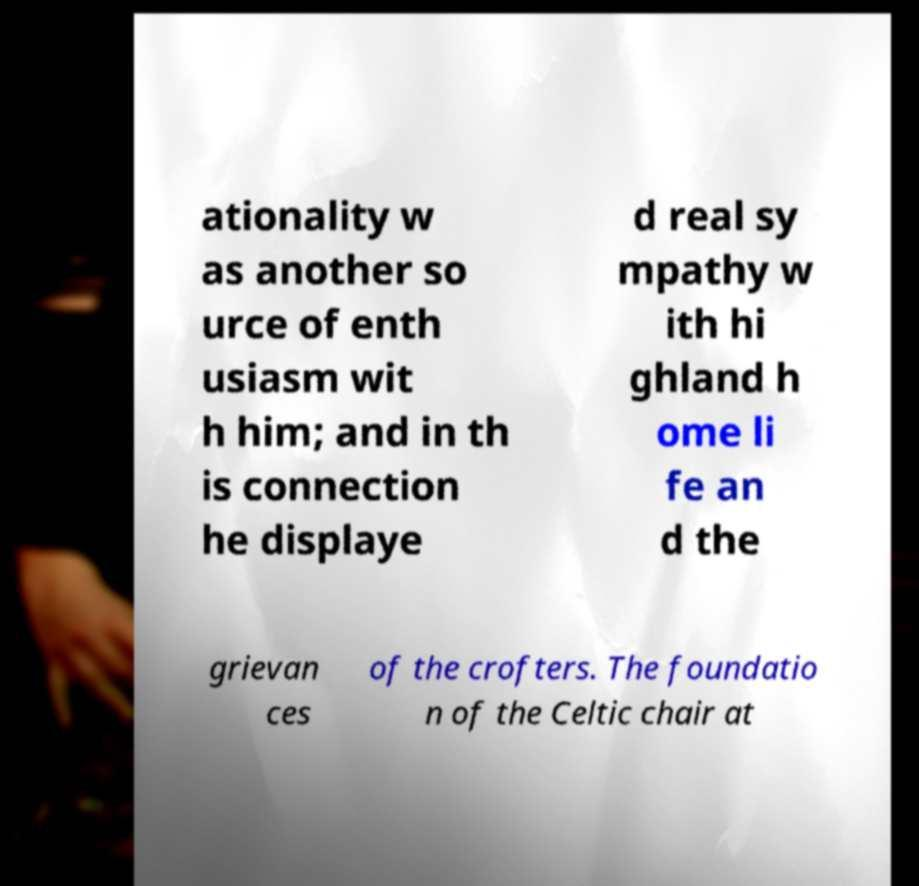I need the written content from this picture converted into text. Can you do that? ationality w as another so urce of enth usiasm wit h him; and in th is connection he displaye d real sy mpathy w ith hi ghland h ome li fe an d the grievan ces of the crofters. The foundatio n of the Celtic chair at 